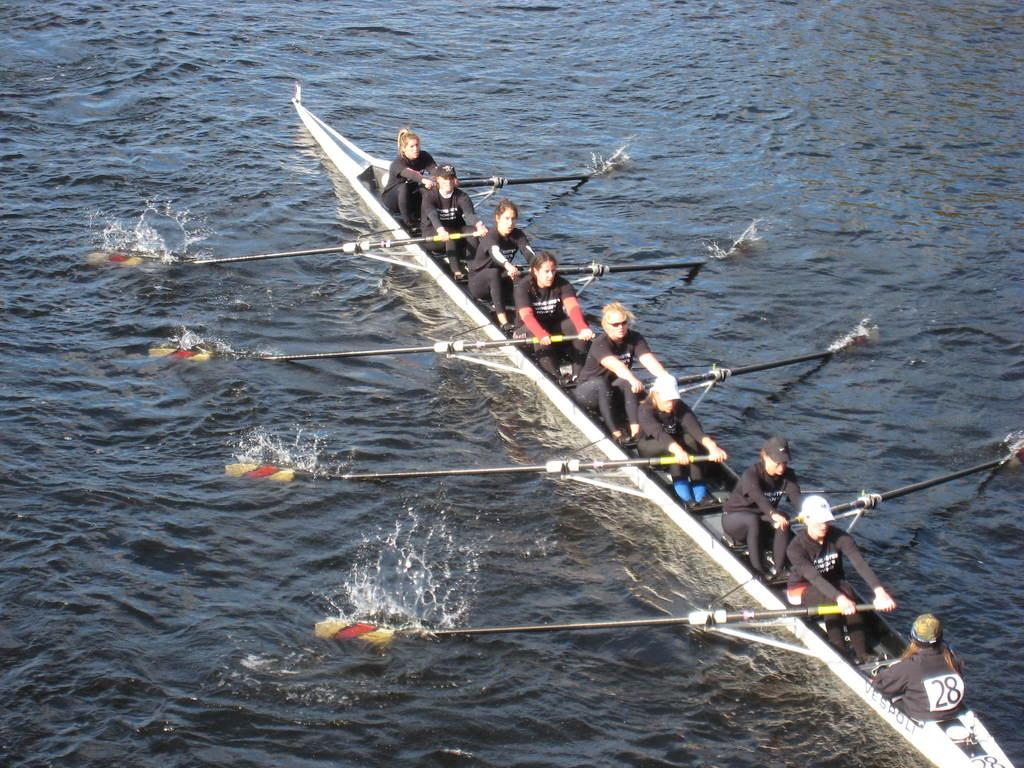What is visible in the image? There is water visible in the image. Who or what is present in the image? There are people in the image. What are the people doing in the image? The people are sitting on a boat. What are the people holding in the image? The people are holding paddles. What type of bell can be heard ringing in the image? There is no bell present in the image, and therefore no sound can be heard. 